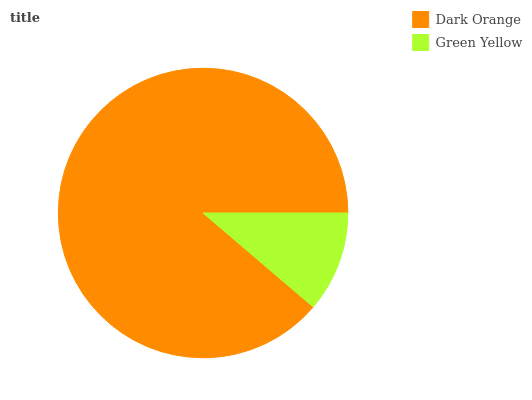Is Green Yellow the minimum?
Answer yes or no. Yes. Is Dark Orange the maximum?
Answer yes or no. Yes. Is Green Yellow the maximum?
Answer yes or no. No. Is Dark Orange greater than Green Yellow?
Answer yes or no. Yes. Is Green Yellow less than Dark Orange?
Answer yes or no. Yes. Is Green Yellow greater than Dark Orange?
Answer yes or no. No. Is Dark Orange less than Green Yellow?
Answer yes or no. No. Is Dark Orange the high median?
Answer yes or no. Yes. Is Green Yellow the low median?
Answer yes or no. Yes. Is Green Yellow the high median?
Answer yes or no. No. Is Dark Orange the low median?
Answer yes or no. No. 